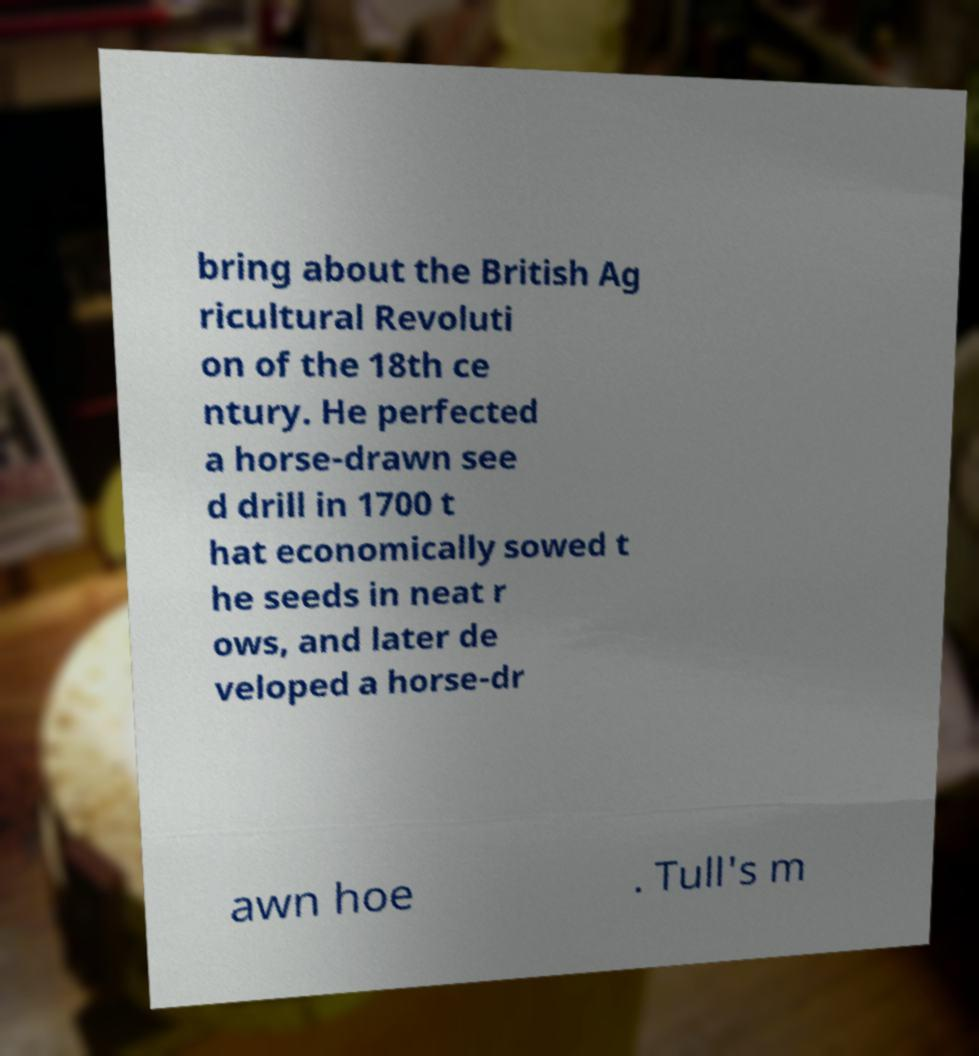Please identify and transcribe the text found in this image. bring about the British Ag ricultural Revoluti on of the 18th ce ntury. He perfected a horse-drawn see d drill in 1700 t hat economically sowed t he seeds in neat r ows, and later de veloped a horse-dr awn hoe . Tull's m 